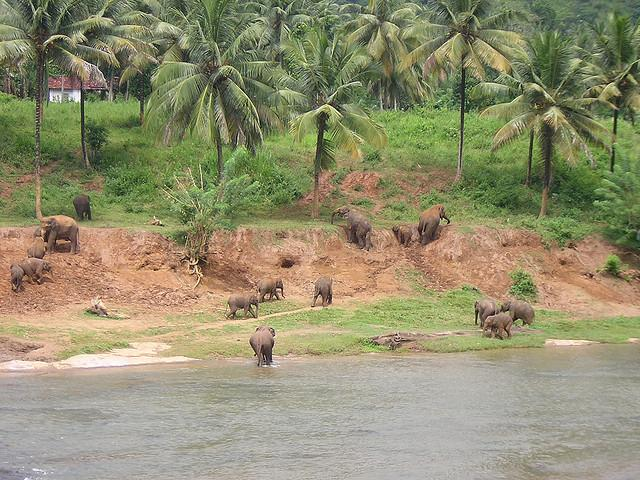What is a unique feature of these animals? Please explain your reasoning. trunk. No other animal has a trunk like an elephant. 